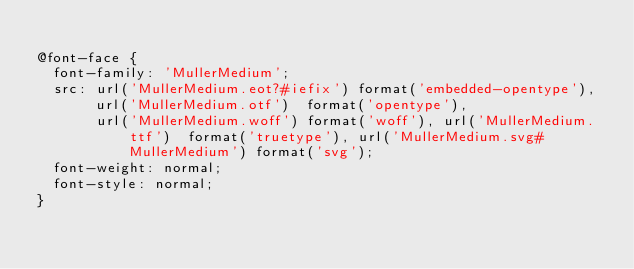<code> <loc_0><loc_0><loc_500><loc_500><_CSS_>
@font-face {
  font-family: 'MullerMedium';
  src: url('MullerMedium.eot?#iefix') format('embedded-opentype'),  url('MullerMedium.otf')  format('opentype'),
	     url('MullerMedium.woff') format('woff'), url('MullerMedium.ttf')  format('truetype'), url('MullerMedium.svg#MullerMedium') format('svg');
  font-weight: normal;
  font-style: normal;
}
</code> 